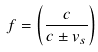Convert formula to latex. <formula><loc_0><loc_0><loc_500><loc_500>f = \left ( { \frac { c } { c \pm v _ { s } } } \right )</formula> 